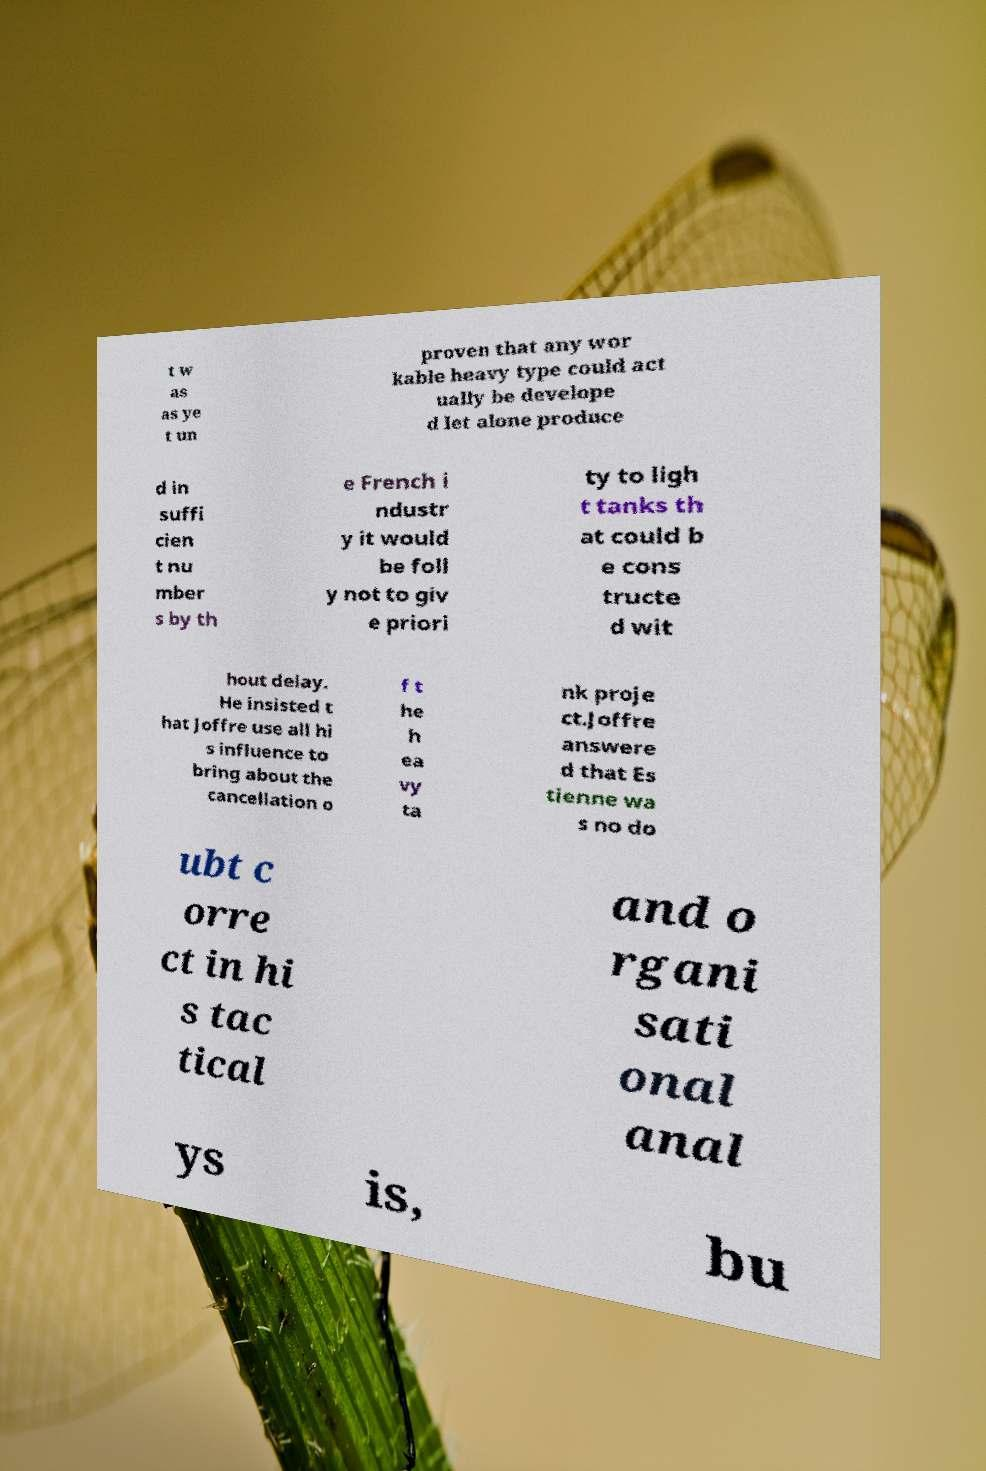Can you accurately transcribe the text from the provided image for me? t w as as ye t un proven that any wor kable heavy type could act ually be develope d let alone produce d in suffi cien t nu mber s by th e French i ndustr y it would be foll y not to giv e priori ty to ligh t tanks th at could b e cons tructe d wit hout delay. He insisted t hat Joffre use all hi s influence to bring about the cancellation o f t he h ea vy ta nk proje ct.Joffre answere d that Es tienne wa s no do ubt c orre ct in hi s tac tical and o rgani sati onal anal ys is, bu 